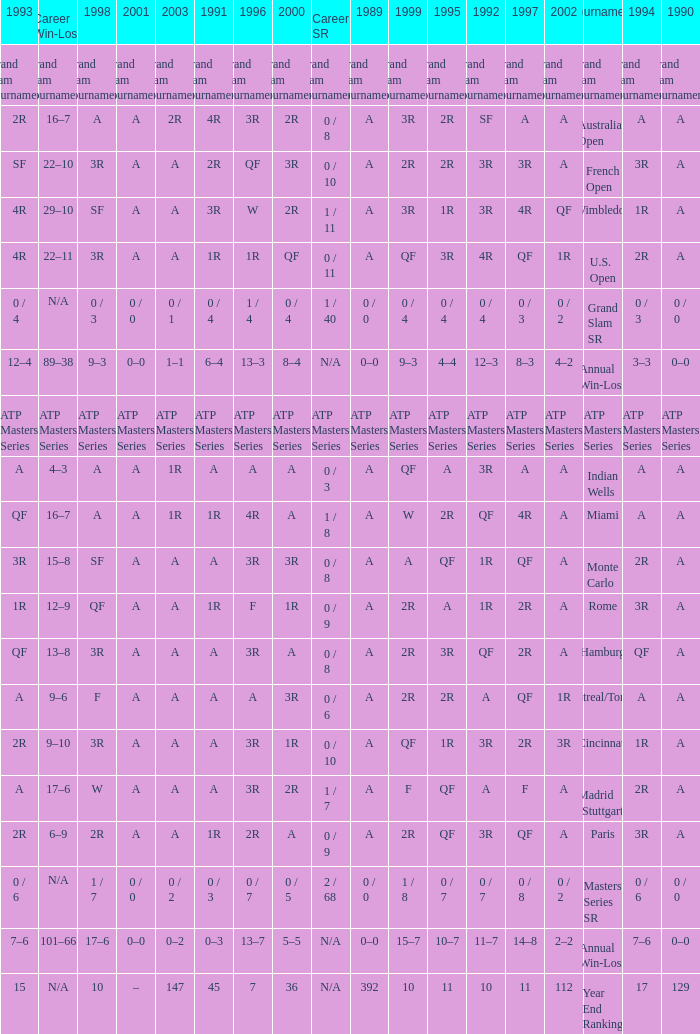What was the value in 1995 for A in 2000 at the Indian Wells tournament? A. 